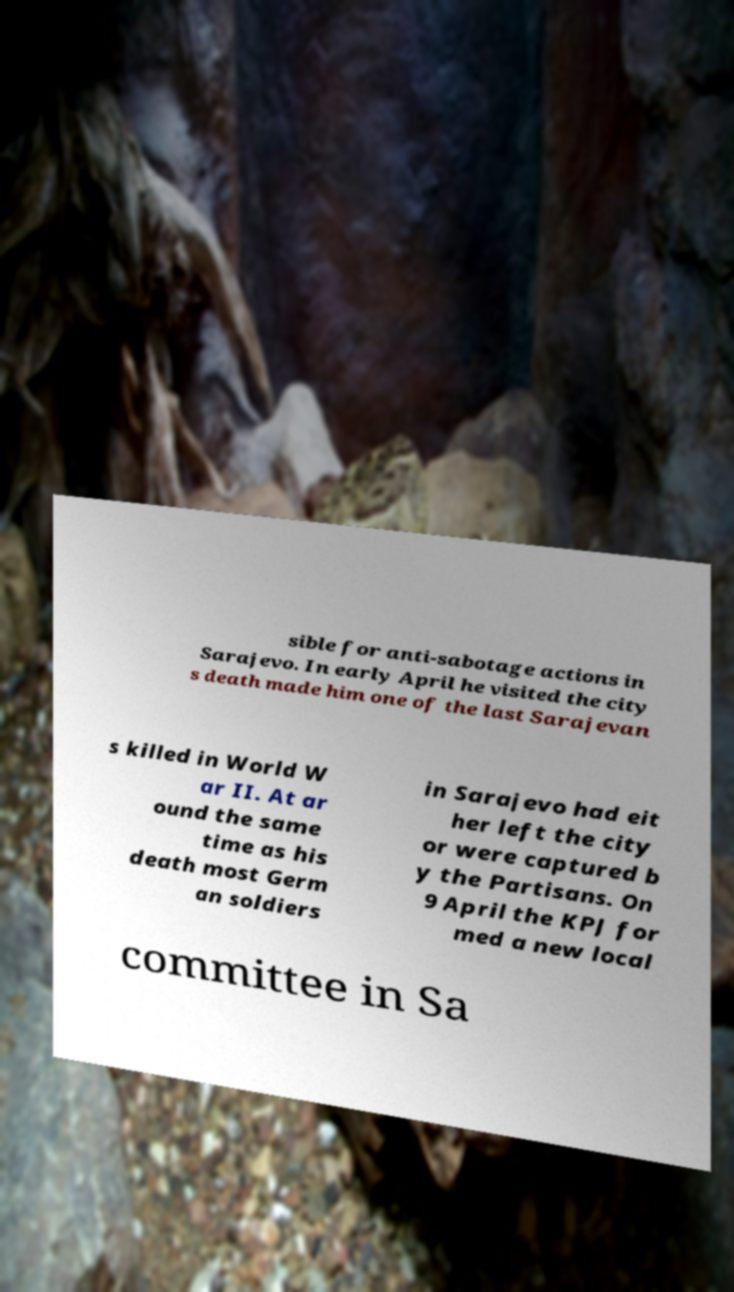Can you accurately transcribe the text from the provided image for me? sible for anti-sabotage actions in Sarajevo. In early April he visited the city s death made him one of the last Sarajevan s killed in World W ar II. At ar ound the same time as his death most Germ an soldiers in Sarajevo had eit her left the city or were captured b y the Partisans. On 9 April the KPJ for med a new local committee in Sa 